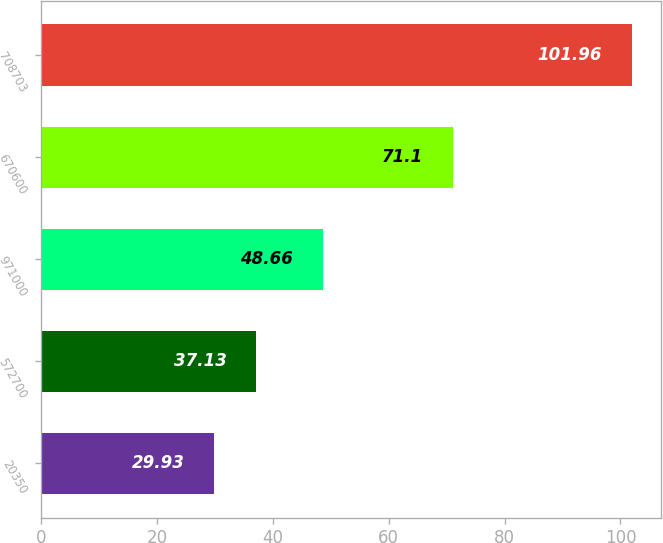Convert chart to OTSL. <chart><loc_0><loc_0><loc_500><loc_500><bar_chart><fcel>20350<fcel>572700<fcel>971000<fcel>670600<fcel>708703<nl><fcel>29.93<fcel>37.13<fcel>48.66<fcel>71.1<fcel>101.96<nl></chart> 